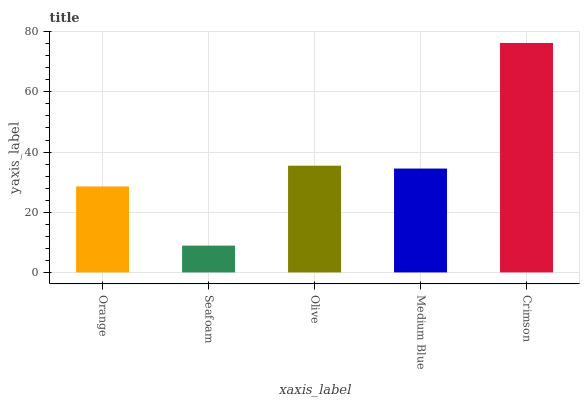Is Seafoam the minimum?
Answer yes or no. Yes. Is Crimson the maximum?
Answer yes or no. Yes. Is Olive the minimum?
Answer yes or no. No. Is Olive the maximum?
Answer yes or no. No. Is Olive greater than Seafoam?
Answer yes or no. Yes. Is Seafoam less than Olive?
Answer yes or no. Yes. Is Seafoam greater than Olive?
Answer yes or no. No. Is Olive less than Seafoam?
Answer yes or no. No. Is Medium Blue the high median?
Answer yes or no. Yes. Is Medium Blue the low median?
Answer yes or no. Yes. Is Orange the high median?
Answer yes or no. No. Is Olive the low median?
Answer yes or no. No. 